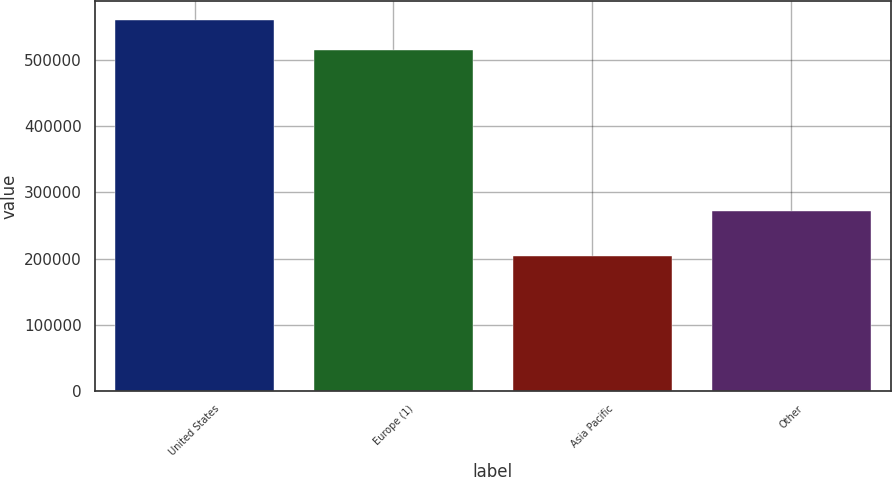<chart> <loc_0><loc_0><loc_500><loc_500><bar_chart><fcel>United States<fcel>Europe (1)<fcel>Asia Pacific<fcel>Other<nl><fcel>561405<fcel>514987<fcel>203538<fcel>271416<nl></chart> 